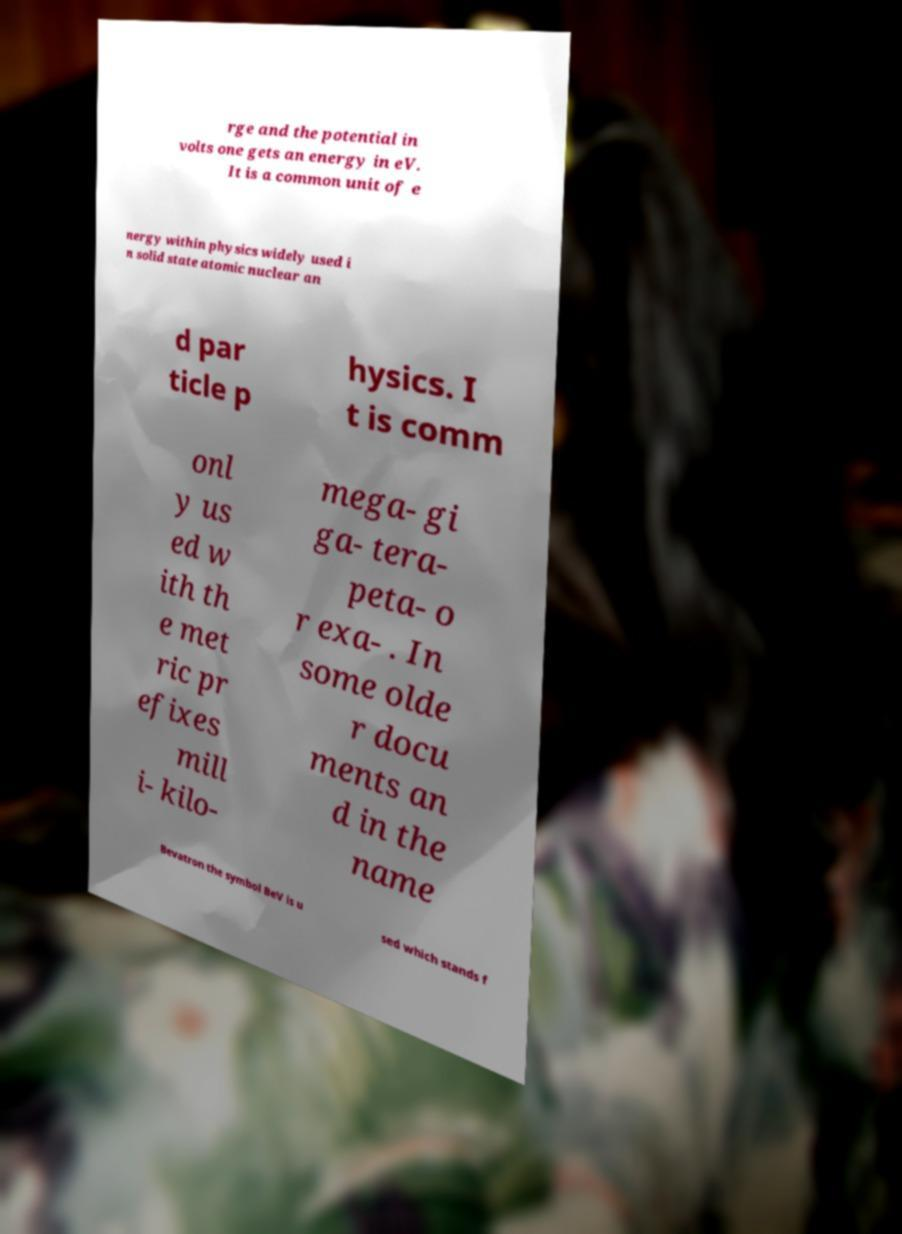Could you assist in decoding the text presented in this image and type it out clearly? rge and the potential in volts one gets an energy in eV. It is a common unit of e nergy within physics widely used i n solid state atomic nuclear an d par ticle p hysics. I t is comm onl y us ed w ith th e met ric pr efixes mill i- kilo- mega- gi ga- tera- peta- o r exa- . In some olde r docu ments an d in the name Bevatron the symbol BeV is u sed which stands f 